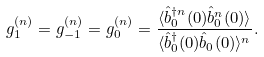<formula> <loc_0><loc_0><loc_500><loc_500>g _ { 1 } ^ { ( n ) } = g _ { - 1 } ^ { ( n ) } = g _ { 0 } ^ { ( n ) } = \frac { \langle \hat { b } _ { 0 } ^ { \dagger n } ( 0 ) \hat { b } _ { 0 } ^ { n } ( 0 ) \rangle } { \langle \hat { b } _ { 0 } ^ { \dagger } ( 0 ) \hat { b } _ { 0 } ( 0 ) \rangle ^ { n } } .</formula> 